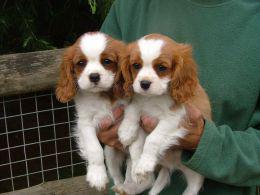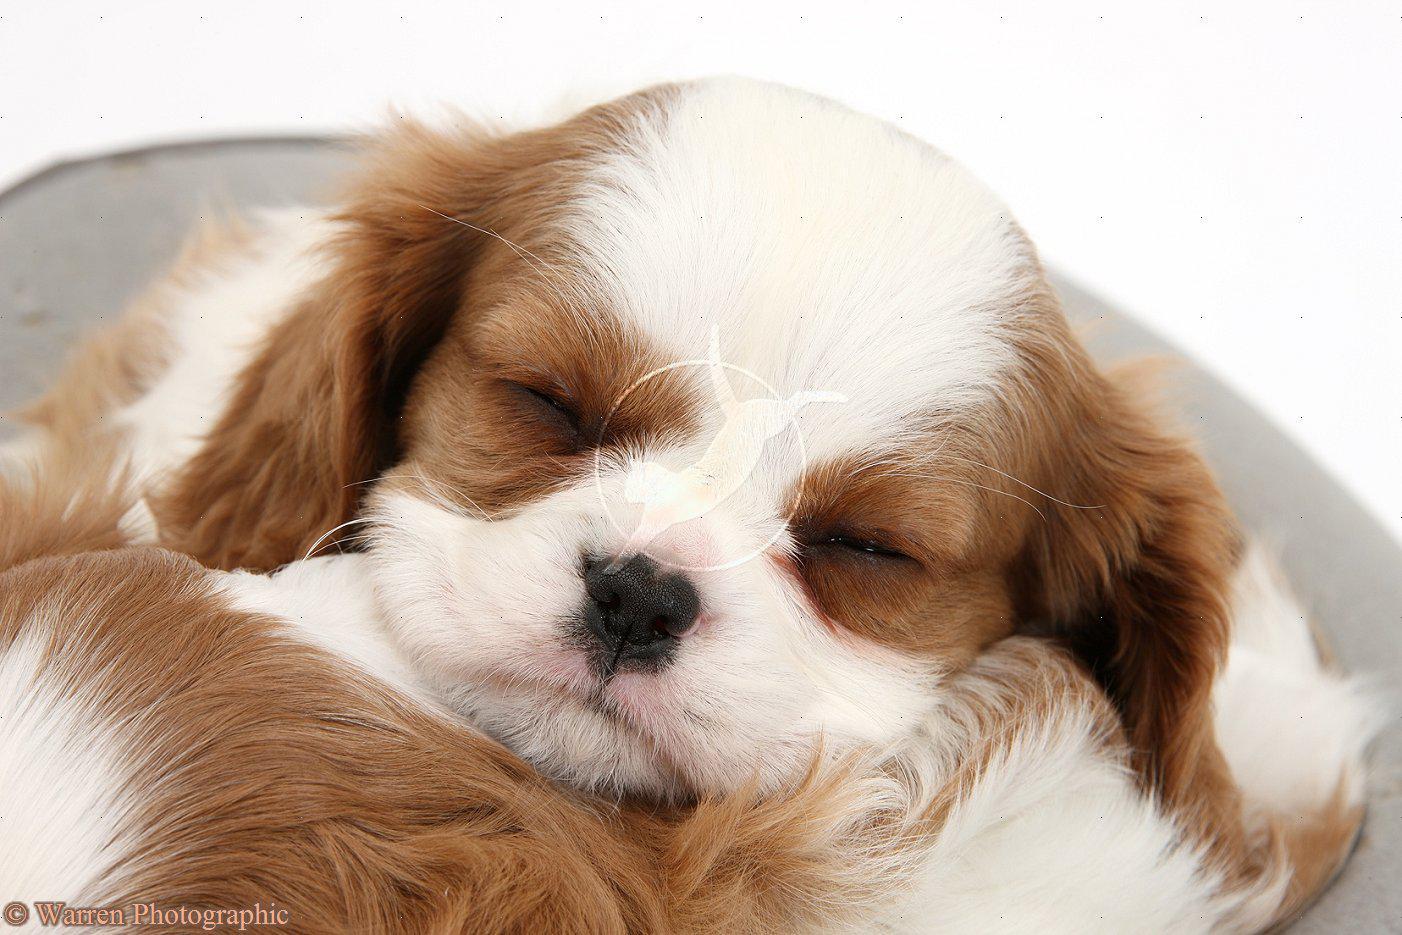The first image is the image on the left, the second image is the image on the right. Given the left and right images, does the statement "There are exactly two animals in the image on the left." hold true? Answer yes or no. Yes. The first image is the image on the left, the second image is the image on the right. Examine the images to the left and right. Is the description "An image shows two furry animals side-by-side." accurate? Answer yes or no. Yes. 